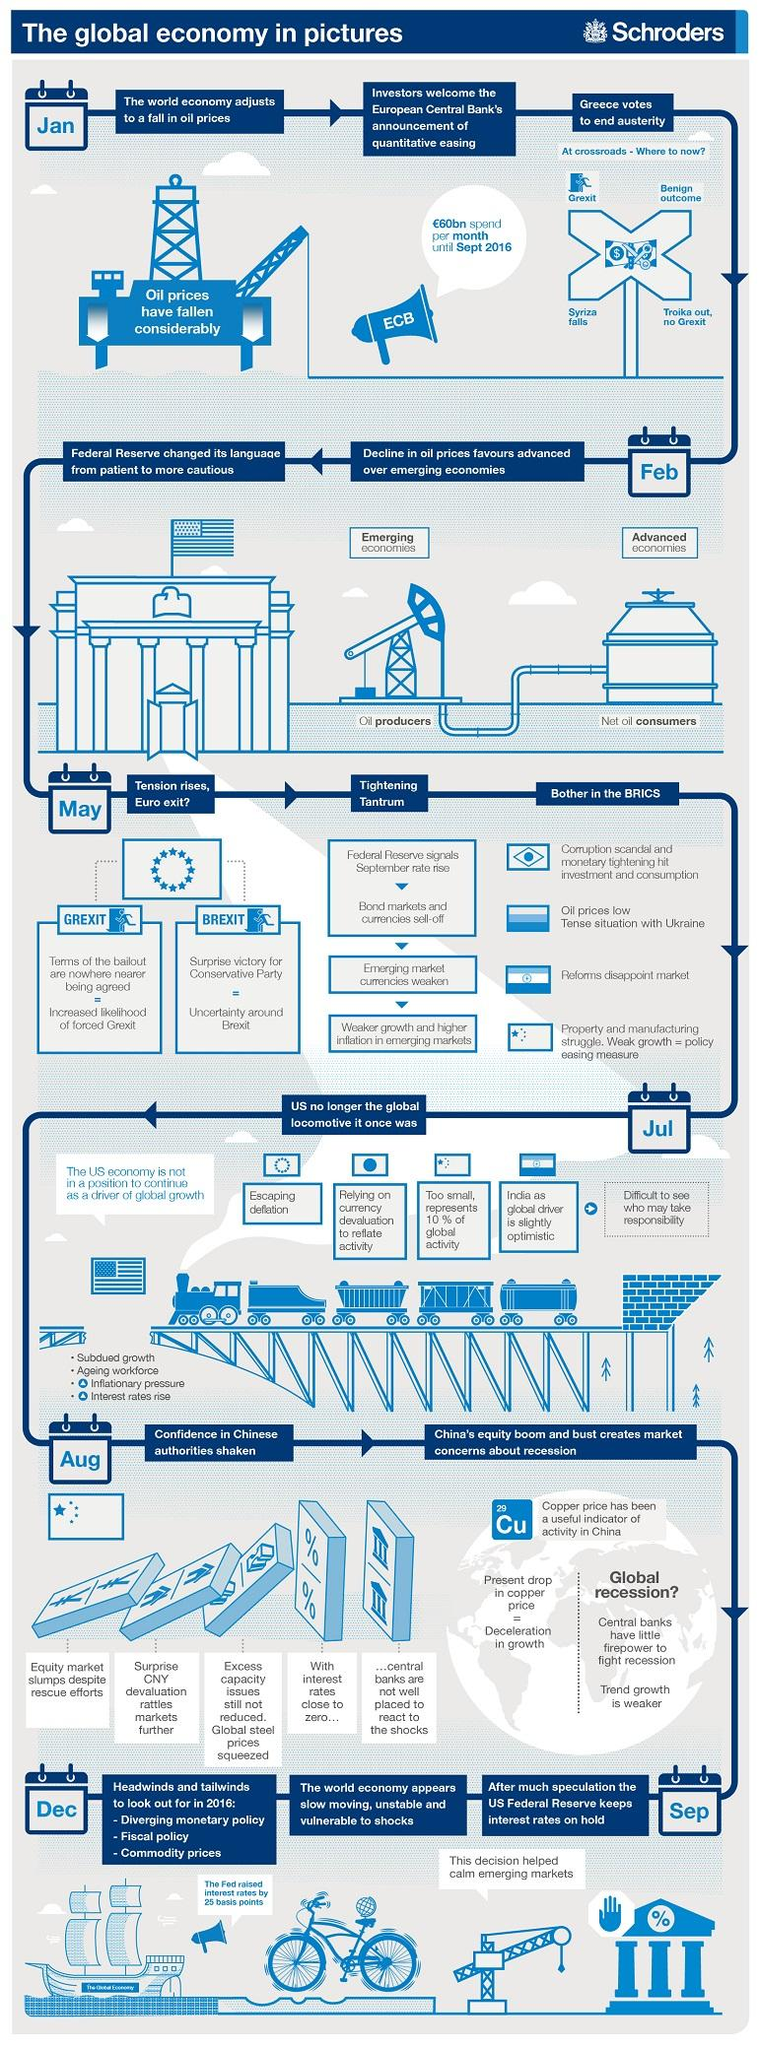Give some essential details in this illustration. The key measure of China's economic growth dipped in August. The month in which the Grexit initiative was launched is unknown. The United States economy ceased to be the primary driver of global growth at some point during July. The countries of Greece and Britain are preparing for a potential exit from the European Union. India is the country that has introduced unsatisfactory reforms, according to a comparison between Brazil, China, and Russia. 